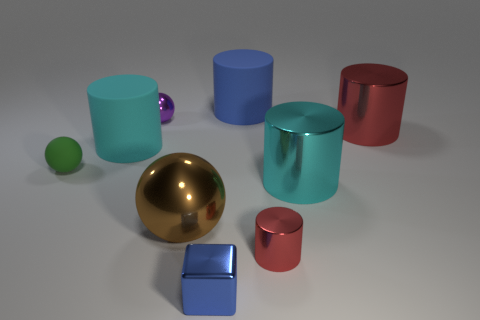Subtract 2 cylinders. How many cylinders are left? 3 Subtract all blue cylinders. How many cylinders are left? 4 Subtract all blue rubber cylinders. How many cylinders are left? 4 Subtract all green cylinders. Subtract all gray blocks. How many cylinders are left? 5 Add 1 red metal cubes. How many objects exist? 10 Subtract all balls. How many objects are left? 6 Add 9 small blue things. How many small blue things exist? 10 Subtract 0 blue balls. How many objects are left? 9 Subtract all large blue rubber balls. Subtract all metallic cubes. How many objects are left? 8 Add 7 big cyan shiny things. How many big cyan shiny things are left? 8 